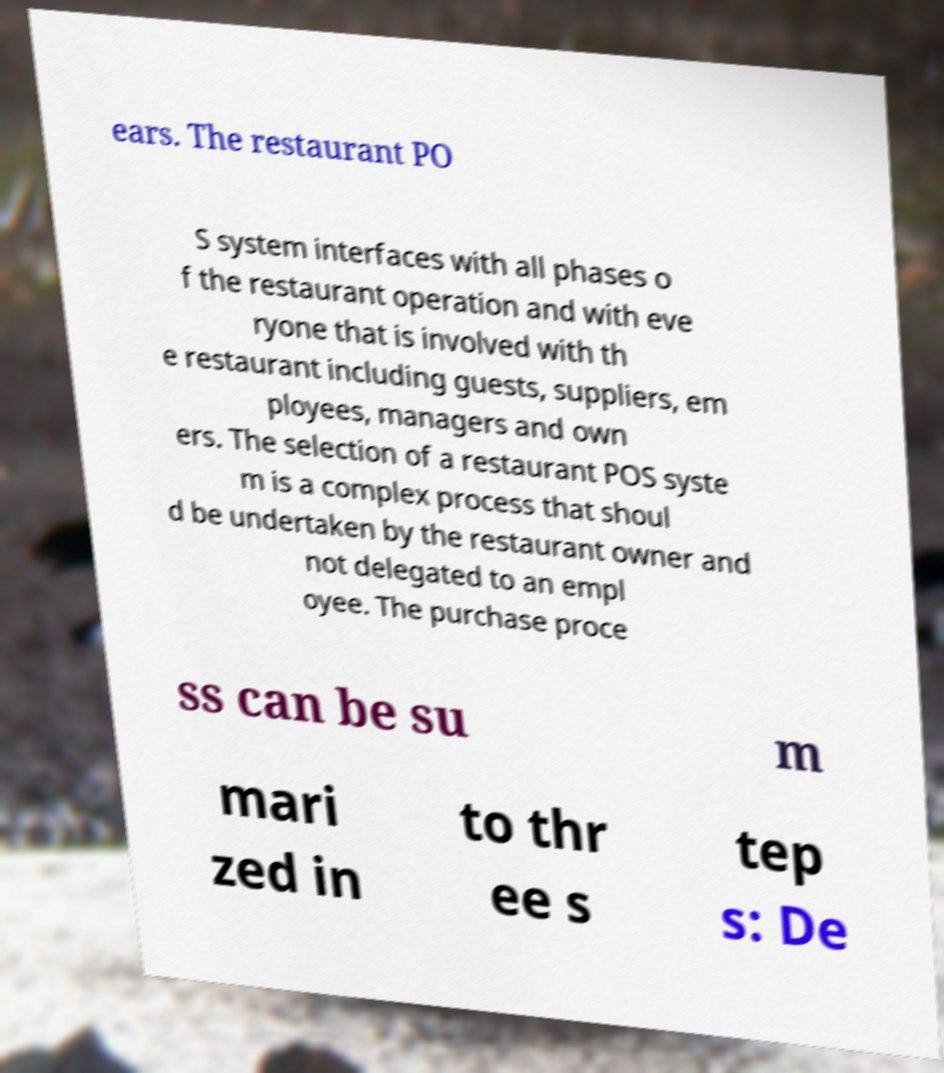Please identify and transcribe the text found in this image. ears. The restaurant PO S system interfaces with all phases o f the restaurant operation and with eve ryone that is involved with th e restaurant including guests, suppliers, em ployees, managers and own ers. The selection of a restaurant POS syste m is a complex process that shoul d be undertaken by the restaurant owner and not delegated to an empl oyee. The purchase proce ss can be su m mari zed in to thr ee s tep s: De 